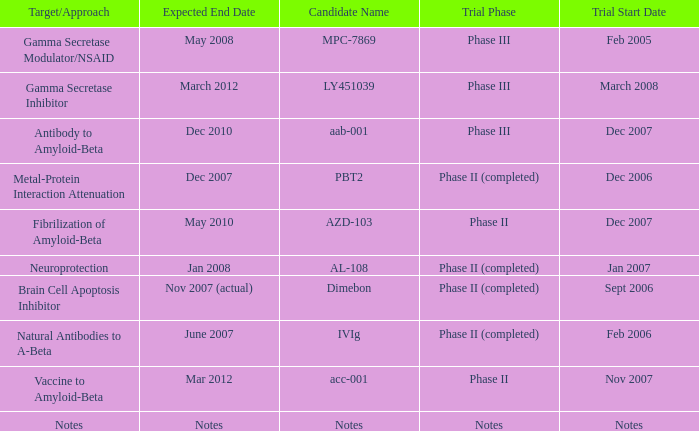What is Expected End Date, when Target/Approach is Notes? Notes. 